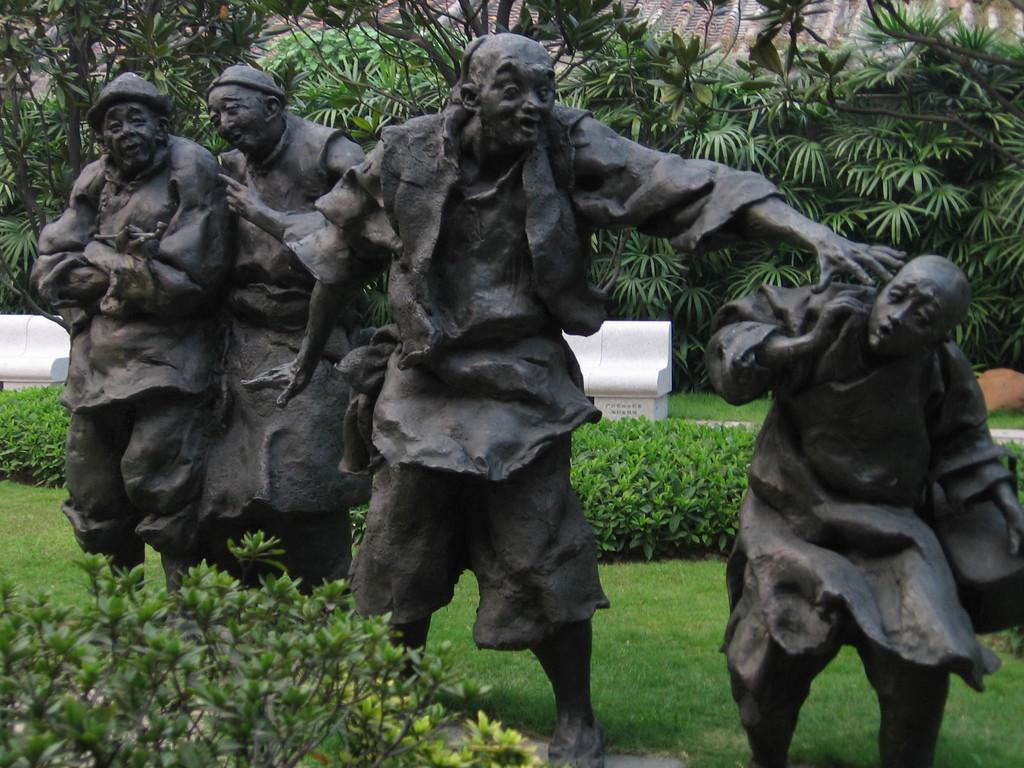What type of objects can be seen in the image? There are statues in the image. What other elements can be found in the image? There are plants, grass, benches, and trees in the image. Can you describe the background of the image? Houses are visible behind the trees in the image. What type of stamp is on the oatmeal in the image? There is no stamp or oatmeal present in the image. What is being served for lunch in the image? The image does not depict any food or lunch being served. 